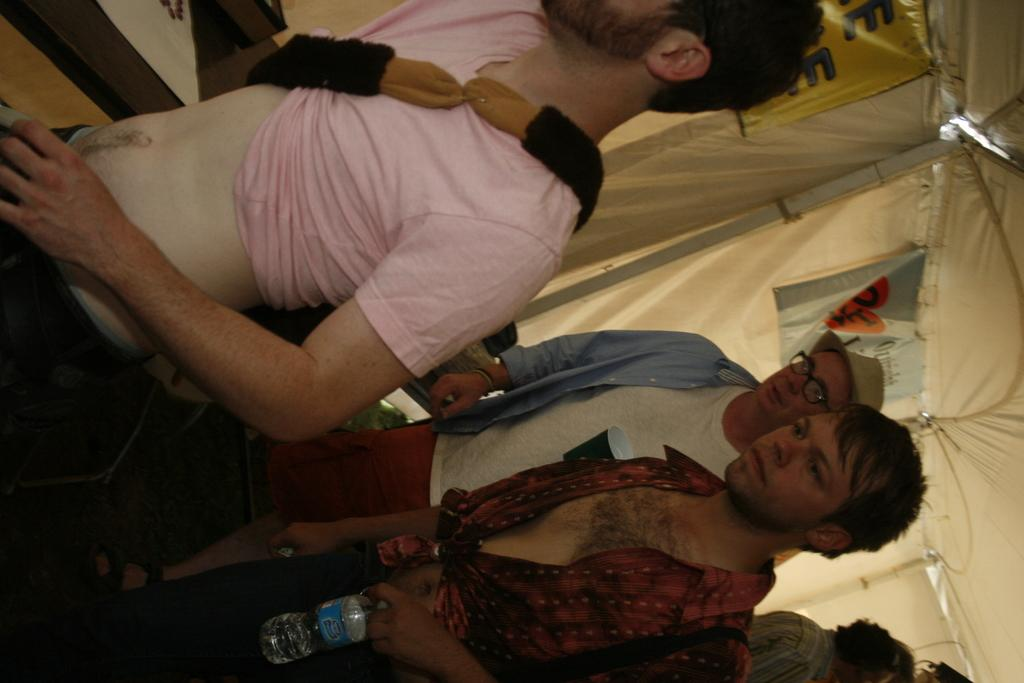What are the people in the image doing? The persons in the image are walking. Where are the people located in the image? The persons are in the center of the image. What type of oil can be seen dripping from the rail in the image? There is no oil or rail present in the image; it features people walking in the center. 